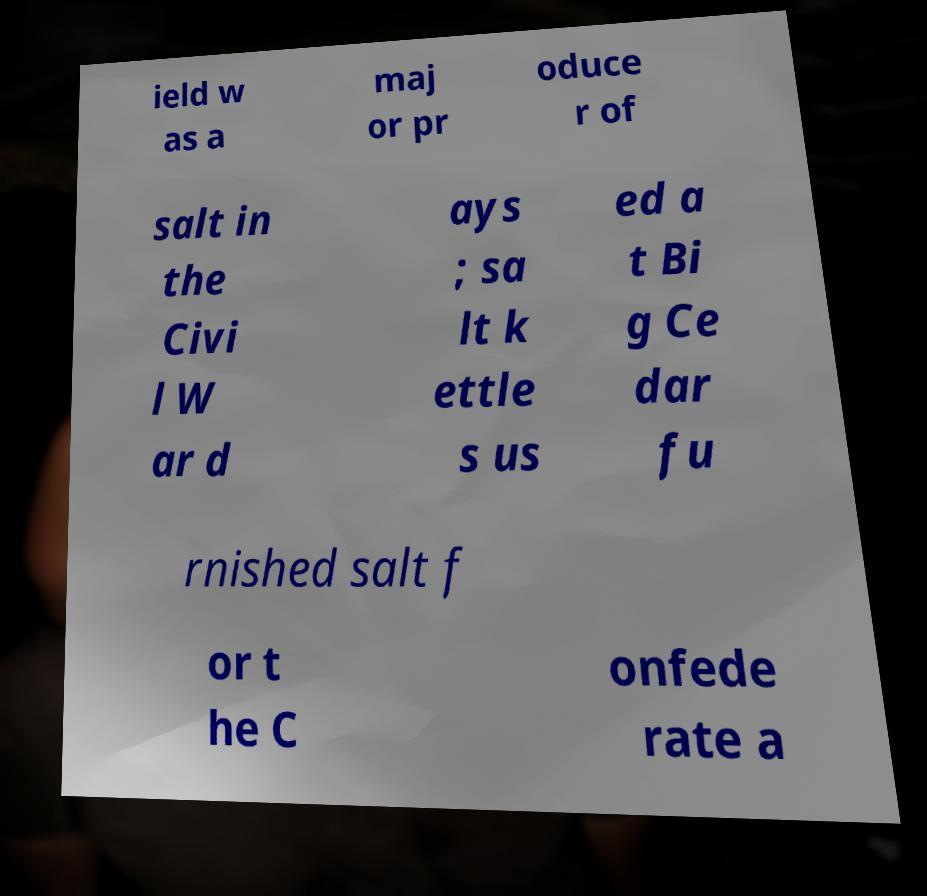Can you accurately transcribe the text from the provided image for me? ield w as a maj or pr oduce r of salt in the Civi l W ar d ays ; sa lt k ettle s us ed a t Bi g Ce dar fu rnished salt f or t he C onfede rate a 